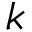Convert formula to latex. <formula><loc_0><loc_0><loc_500><loc_500>k</formula> 